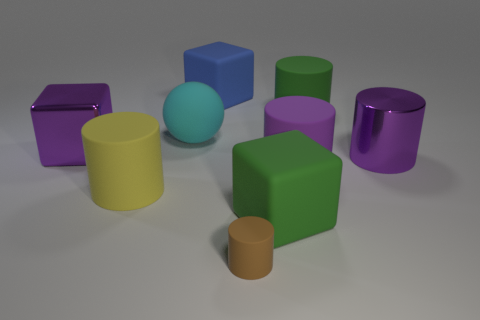The large purple thing that is in front of the purple metal thing on the right side of the purple rubber thing is made of what material?
Provide a short and direct response. Rubber. How big is the purple matte cylinder?
Keep it short and to the point. Large. What size is the cylinder that is made of the same material as the purple block?
Provide a succinct answer. Large. There is a shiny thing to the right of the yellow matte cylinder; is it the same size as the small cylinder?
Your answer should be compact. No. The large purple thing behind the big shiny object that is on the right side of the matte cylinder that is in front of the yellow cylinder is what shape?
Your response must be concise. Cube. How many objects are tiny gray shiny objects or cubes behind the purple matte object?
Offer a terse response. 2. What is the size of the matte cylinder that is left of the brown object?
Provide a short and direct response. Large. What shape is the metal object that is the same color as the metal cube?
Ensure brevity in your answer.  Cylinder. Are the yellow cylinder and the large block behind the big cyan matte object made of the same material?
Your answer should be very brief. Yes. There is a big green thing that is in front of the big purple shiny thing right of the brown object; how many yellow rubber cylinders are in front of it?
Provide a short and direct response. 0. 